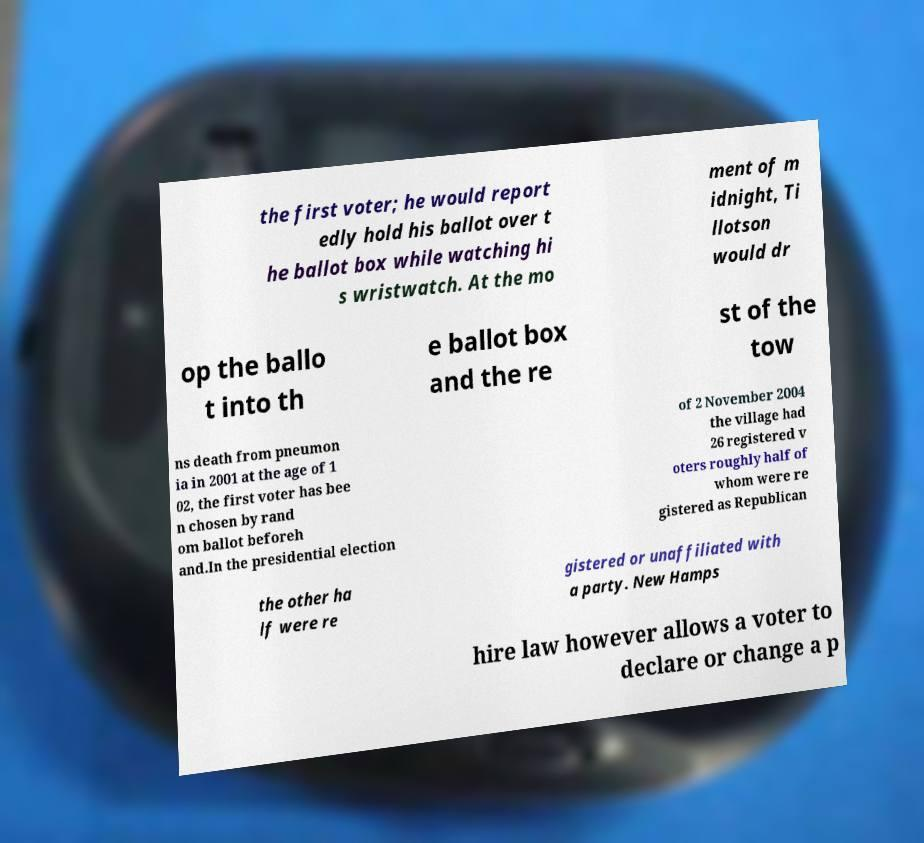I need the written content from this picture converted into text. Can you do that? the first voter; he would report edly hold his ballot over t he ballot box while watching hi s wristwatch. At the mo ment of m idnight, Ti llotson would dr op the ballo t into th e ballot box and the re st of the tow ns death from pneumon ia in 2001 at the age of 1 02, the first voter has bee n chosen by rand om ballot beforeh and.In the presidential election of 2 November 2004 the village had 26 registered v oters roughly half of whom were re gistered as Republican the other ha lf were re gistered or unaffiliated with a party. New Hamps hire law however allows a voter to declare or change a p 